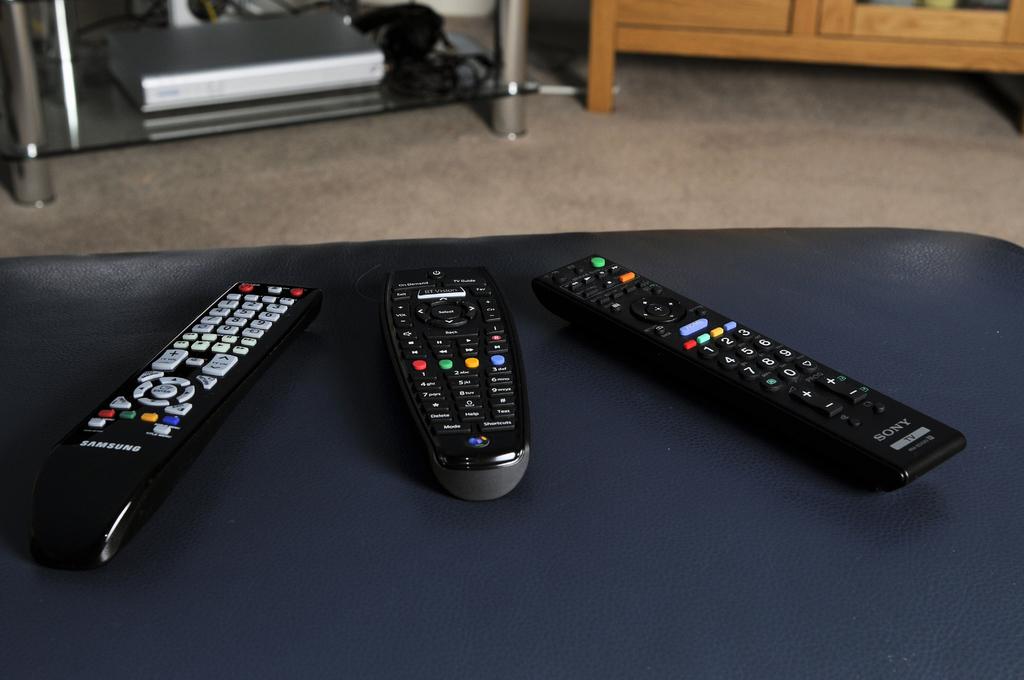What is the brand of remote on the left?
Offer a very short reply. Samsung. Whats the name of the remote?
Your answer should be compact. Unanswerable. 